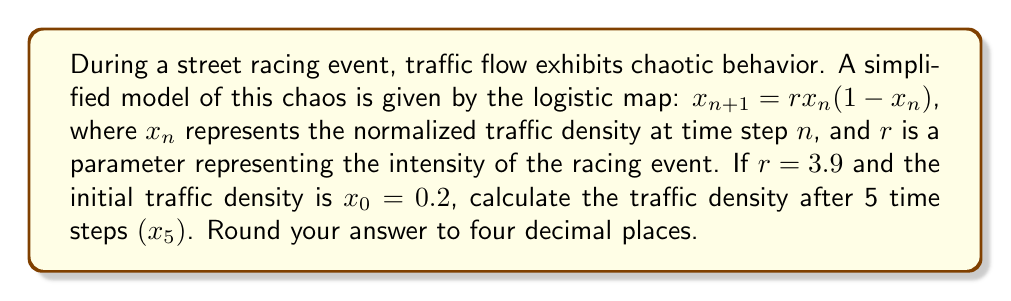Solve this math problem. To solve this problem, we need to iterate the logistic map equation five times:

1) For $n=0$: 
   $x_1 = 3.9 \cdot 0.2 \cdot (1-0.2) = 0.624$

2) For $n=1$:
   $x_2 = 3.9 \cdot 0.624 \cdot (1-0.624) = 0.9165696$

3) For $n=2$:
   $x_3 = 3.9 \cdot 0.9165696 \cdot (1-0.9165696) = 0.2990201$

4) For $n=3$:
   $x_4 = 3.9 \cdot 0.2990201 \cdot (1-0.2990201) = 0.8186196$

5) For $n=4$:
   $x_5 = 3.9 \cdot 0.8186196 \cdot (1-0.8186196) = 0.5803399$

Rounding to four decimal places, we get 0.5803.

This demonstrates the chaotic nature of traffic flow during street racing events, as small changes in initial conditions can lead to vastly different outcomes over time.
Answer: 0.5803 